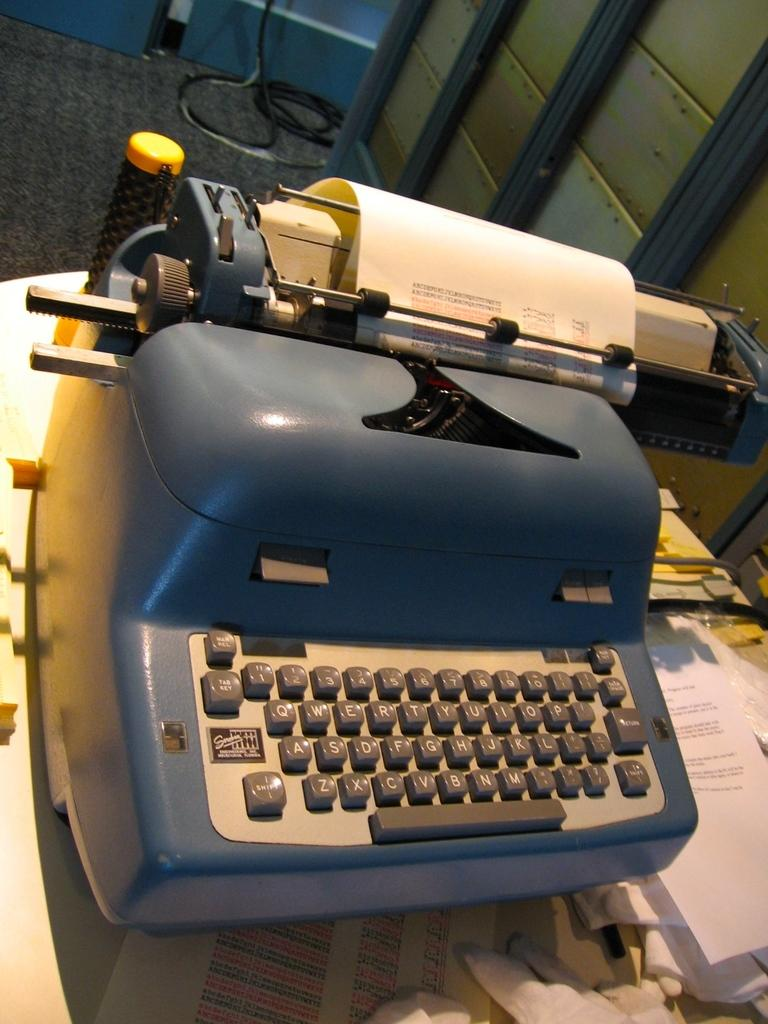Provide a one-sentence caption for the provided image. An antique typewriter has the shift key in the lower-left corner of the keyboard. 